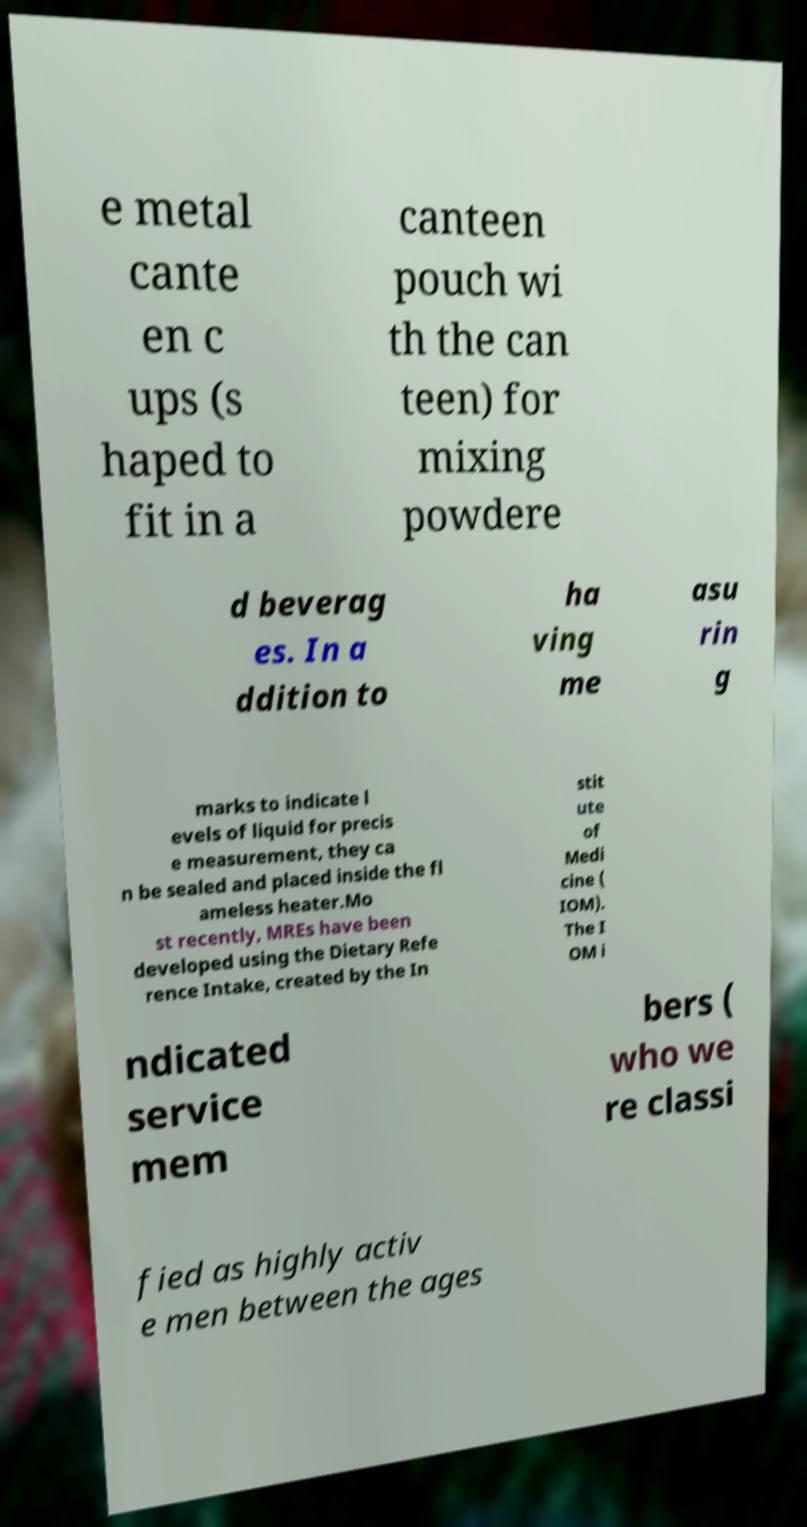Please read and relay the text visible in this image. What does it say? e metal cante en c ups (s haped to fit in a canteen pouch wi th the can teen) for mixing powdere d beverag es. In a ddition to ha ving me asu rin g marks to indicate l evels of liquid for precis e measurement, they ca n be sealed and placed inside the fl ameless heater.Mo st recently, MREs have been developed using the Dietary Refe rence Intake, created by the In stit ute of Medi cine ( IOM). The I OM i ndicated service mem bers ( who we re classi fied as highly activ e men between the ages 